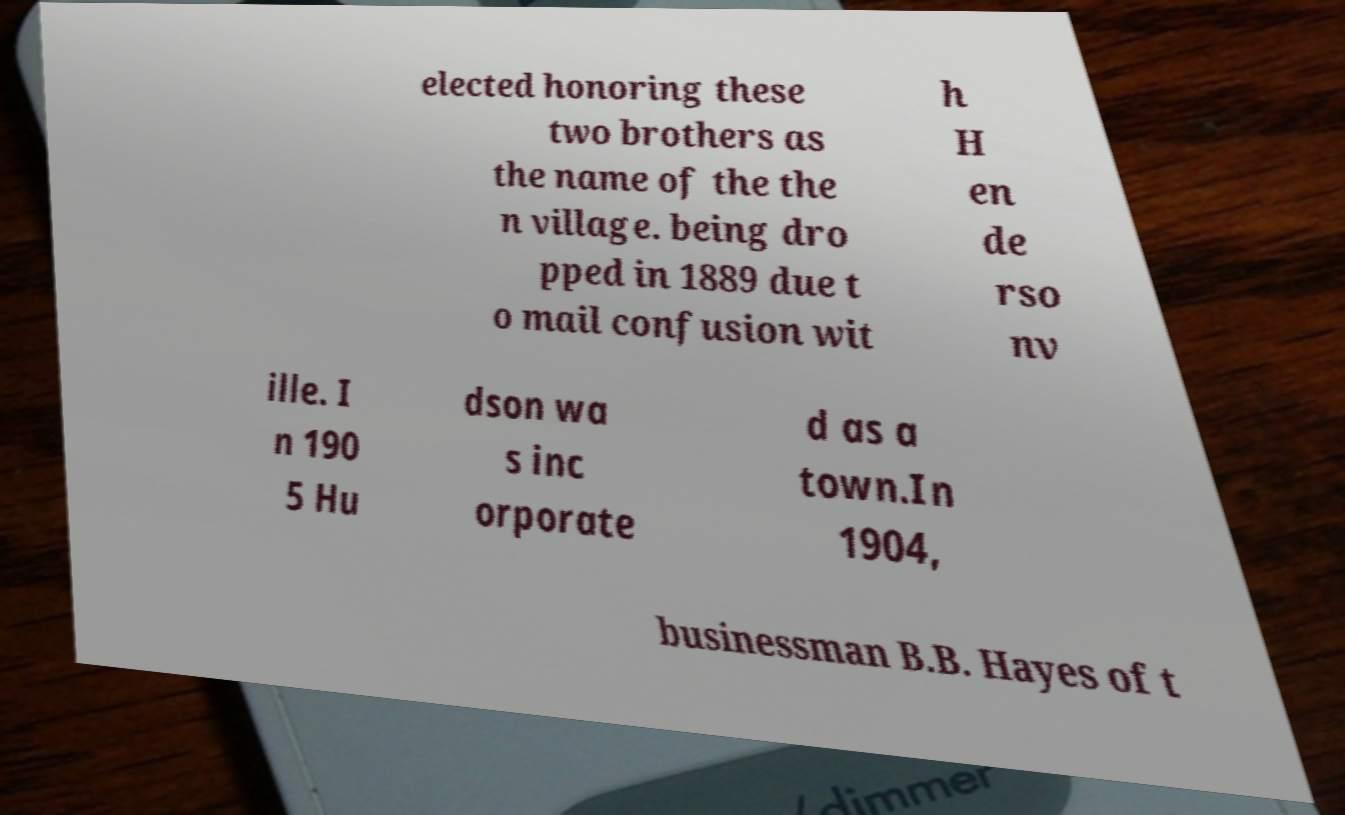Please identify and transcribe the text found in this image. elected honoring these two brothers as the name of the the n village. being dro pped in 1889 due t o mail confusion wit h H en de rso nv ille. I n 190 5 Hu dson wa s inc orporate d as a town.In 1904, businessman B.B. Hayes of t 